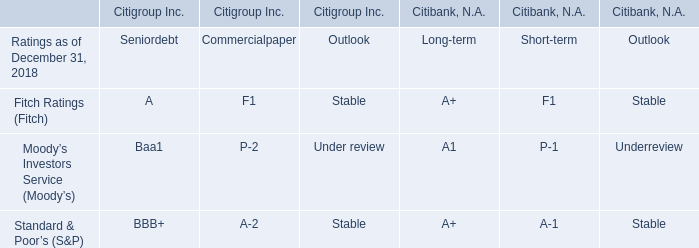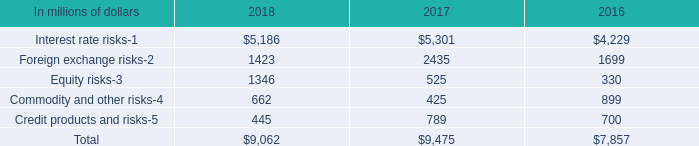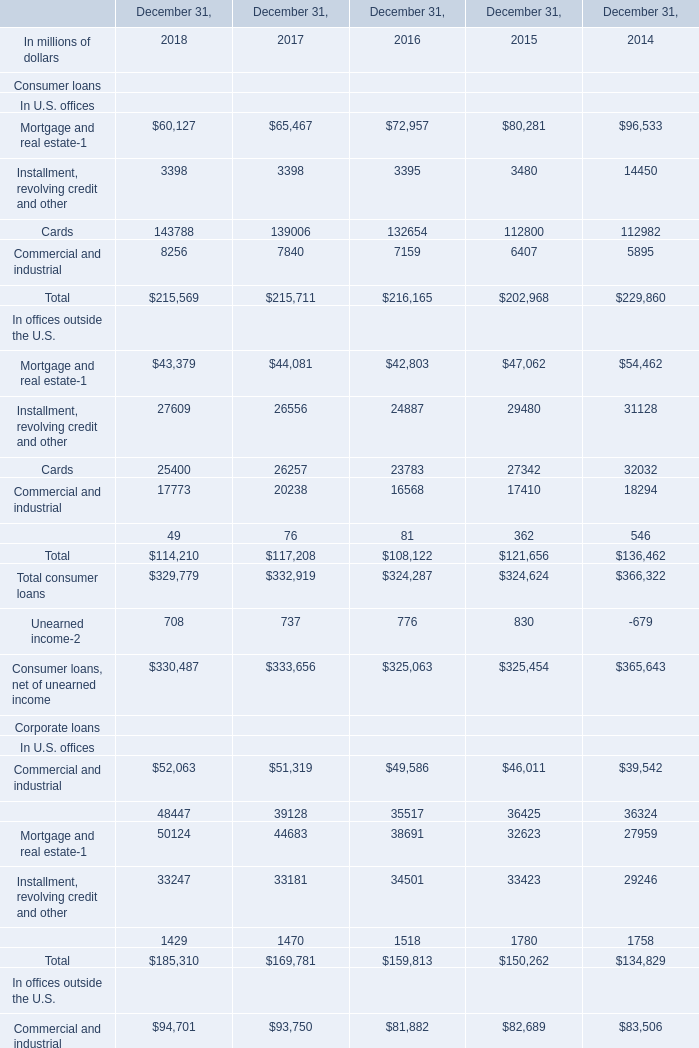What's the current growth rate of Mortgage and real estate? (in %) 
Computations: ((60127 - 65467) / 65467)
Answer: -0.08157. 